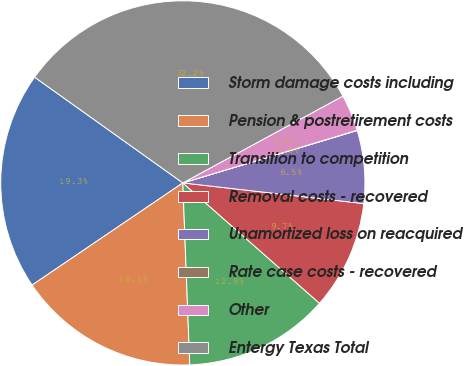Convert chart to OTSL. <chart><loc_0><loc_0><loc_500><loc_500><pie_chart><fcel>Storm damage costs including<fcel>Pension & postretirement costs<fcel>Transition to competition<fcel>Removal costs - recovered<fcel>Unamortized loss on reacquired<fcel>Rate case costs - recovered<fcel>Other<fcel>Entergy Texas Total<nl><fcel>19.34%<fcel>16.12%<fcel>12.9%<fcel>9.68%<fcel>6.46%<fcel>0.02%<fcel>3.24%<fcel>32.22%<nl></chart> 